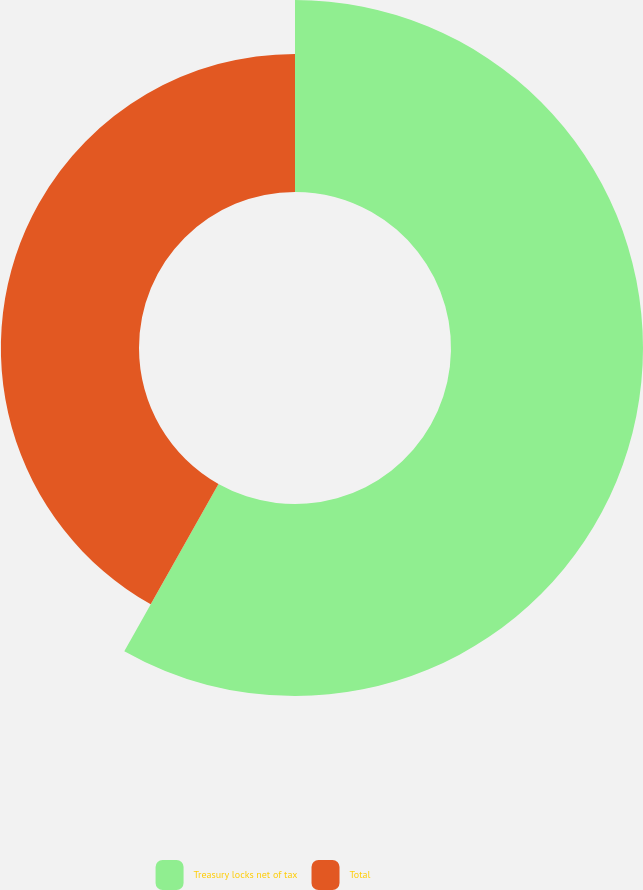<chart> <loc_0><loc_0><loc_500><loc_500><pie_chart><fcel>Treasury locks net of tax<fcel>Total<nl><fcel>58.16%<fcel>41.84%<nl></chart> 